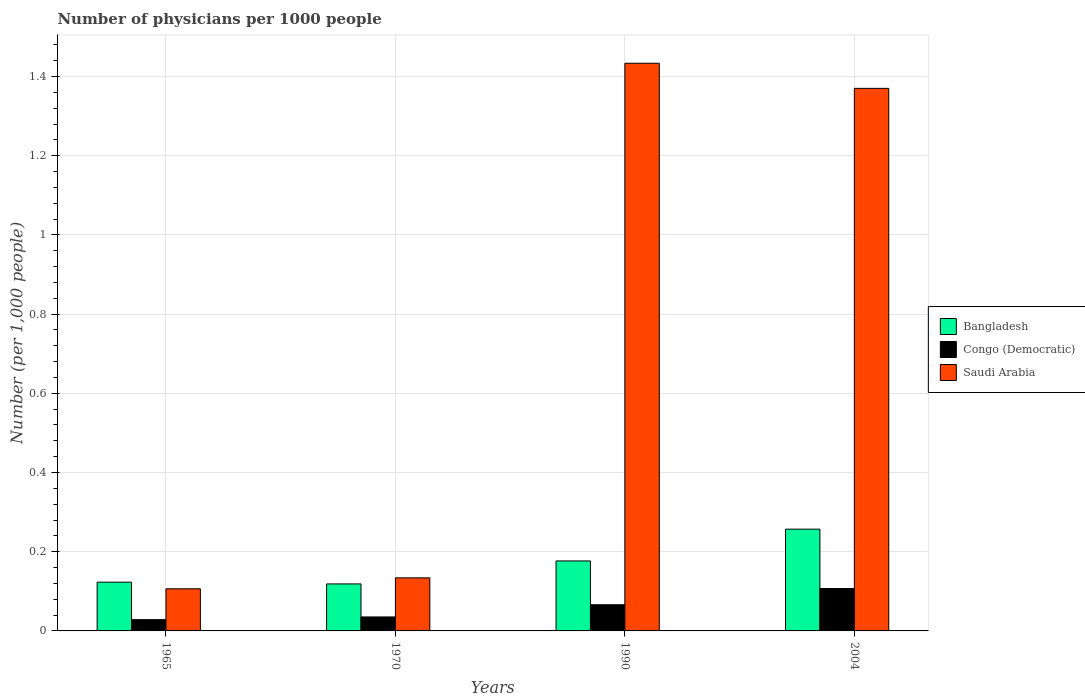Are the number of bars per tick equal to the number of legend labels?
Make the answer very short. Yes. Are the number of bars on each tick of the X-axis equal?
Provide a short and direct response. Yes. How many bars are there on the 1st tick from the left?
Your response must be concise. 3. How many bars are there on the 4th tick from the right?
Make the answer very short. 3. What is the label of the 1st group of bars from the left?
Offer a very short reply. 1965. What is the number of physicians in Saudi Arabia in 1970?
Provide a short and direct response. 0.13. Across all years, what is the maximum number of physicians in Congo (Democratic)?
Give a very brief answer. 0.11. Across all years, what is the minimum number of physicians in Bangladesh?
Provide a short and direct response. 0.12. In which year was the number of physicians in Congo (Democratic) minimum?
Provide a succinct answer. 1965. What is the total number of physicians in Bangladesh in the graph?
Your answer should be very brief. 0.68. What is the difference between the number of physicians in Bangladesh in 1965 and that in 1970?
Provide a succinct answer. 0. What is the difference between the number of physicians in Bangladesh in 1970 and the number of physicians in Saudi Arabia in 1990?
Give a very brief answer. -1.31. What is the average number of physicians in Congo (Democratic) per year?
Your response must be concise. 0.06. In the year 1965, what is the difference between the number of physicians in Bangladesh and number of physicians in Saudi Arabia?
Your answer should be very brief. 0.02. In how many years, is the number of physicians in Saudi Arabia greater than 0.32?
Make the answer very short. 2. What is the ratio of the number of physicians in Bangladesh in 1970 to that in 1990?
Your answer should be compact. 0.67. Is the difference between the number of physicians in Bangladesh in 1965 and 1970 greater than the difference between the number of physicians in Saudi Arabia in 1965 and 1970?
Provide a short and direct response. Yes. What is the difference between the highest and the second highest number of physicians in Bangladesh?
Ensure brevity in your answer.  0.08. What is the difference between the highest and the lowest number of physicians in Bangladesh?
Provide a short and direct response. 0.14. In how many years, is the number of physicians in Saudi Arabia greater than the average number of physicians in Saudi Arabia taken over all years?
Offer a terse response. 2. What does the 2nd bar from the left in 1970 represents?
Give a very brief answer. Congo (Democratic). What does the 2nd bar from the right in 1965 represents?
Ensure brevity in your answer.  Congo (Democratic). Is it the case that in every year, the sum of the number of physicians in Congo (Democratic) and number of physicians in Bangladesh is greater than the number of physicians in Saudi Arabia?
Your response must be concise. No. How many bars are there?
Your response must be concise. 12. How many years are there in the graph?
Your answer should be compact. 4. What is the difference between two consecutive major ticks on the Y-axis?
Keep it short and to the point. 0.2. Does the graph contain grids?
Your answer should be very brief. Yes. Where does the legend appear in the graph?
Your answer should be very brief. Center right. What is the title of the graph?
Offer a very short reply. Number of physicians per 1000 people. Does "United Kingdom" appear as one of the legend labels in the graph?
Offer a very short reply. No. What is the label or title of the Y-axis?
Your answer should be compact. Number (per 1,0 people). What is the Number (per 1,000 people) in Bangladesh in 1965?
Give a very brief answer. 0.12. What is the Number (per 1,000 people) of Congo (Democratic) in 1965?
Make the answer very short. 0.03. What is the Number (per 1,000 people) in Saudi Arabia in 1965?
Your response must be concise. 0.11. What is the Number (per 1,000 people) of Bangladesh in 1970?
Provide a short and direct response. 0.12. What is the Number (per 1,000 people) of Congo (Democratic) in 1970?
Your response must be concise. 0.04. What is the Number (per 1,000 people) in Saudi Arabia in 1970?
Keep it short and to the point. 0.13. What is the Number (per 1,000 people) of Bangladesh in 1990?
Make the answer very short. 0.18. What is the Number (per 1,000 people) of Congo (Democratic) in 1990?
Make the answer very short. 0.07. What is the Number (per 1,000 people) of Saudi Arabia in 1990?
Provide a succinct answer. 1.43. What is the Number (per 1,000 people) in Bangladesh in 2004?
Offer a terse response. 0.26. What is the Number (per 1,000 people) in Congo (Democratic) in 2004?
Provide a succinct answer. 0.11. What is the Number (per 1,000 people) in Saudi Arabia in 2004?
Ensure brevity in your answer.  1.37. Across all years, what is the maximum Number (per 1,000 people) of Bangladesh?
Your answer should be very brief. 0.26. Across all years, what is the maximum Number (per 1,000 people) in Congo (Democratic)?
Provide a short and direct response. 0.11. Across all years, what is the maximum Number (per 1,000 people) in Saudi Arabia?
Offer a very short reply. 1.43. Across all years, what is the minimum Number (per 1,000 people) of Bangladesh?
Ensure brevity in your answer.  0.12. Across all years, what is the minimum Number (per 1,000 people) of Congo (Democratic)?
Offer a terse response. 0.03. Across all years, what is the minimum Number (per 1,000 people) in Saudi Arabia?
Your answer should be compact. 0.11. What is the total Number (per 1,000 people) in Bangladesh in the graph?
Offer a terse response. 0.68. What is the total Number (per 1,000 people) in Congo (Democratic) in the graph?
Offer a terse response. 0.24. What is the total Number (per 1,000 people) of Saudi Arabia in the graph?
Ensure brevity in your answer.  3.04. What is the difference between the Number (per 1,000 people) in Bangladesh in 1965 and that in 1970?
Offer a very short reply. 0. What is the difference between the Number (per 1,000 people) in Congo (Democratic) in 1965 and that in 1970?
Provide a succinct answer. -0.01. What is the difference between the Number (per 1,000 people) of Saudi Arabia in 1965 and that in 1970?
Your answer should be compact. -0.03. What is the difference between the Number (per 1,000 people) in Bangladesh in 1965 and that in 1990?
Make the answer very short. -0.05. What is the difference between the Number (per 1,000 people) of Congo (Democratic) in 1965 and that in 1990?
Your response must be concise. -0.04. What is the difference between the Number (per 1,000 people) of Saudi Arabia in 1965 and that in 1990?
Your response must be concise. -1.33. What is the difference between the Number (per 1,000 people) of Bangladesh in 1965 and that in 2004?
Keep it short and to the point. -0.13. What is the difference between the Number (per 1,000 people) in Congo (Democratic) in 1965 and that in 2004?
Provide a short and direct response. -0.08. What is the difference between the Number (per 1,000 people) in Saudi Arabia in 1965 and that in 2004?
Your response must be concise. -1.26. What is the difference between the Number (per 1,000 people) in Bangladesh in 1970 and that in 1990?
Offer a very short reply. -0.06. What is the difference between the Number (per 1,000 people) in Congo (Democratic) in 1970 and that in 1990?
Your answer should be compact. -0.03. What is the difference between the Number (per 1,000 people) of Saudi Arabia in 1970 and that in 1990?
Your answer should be very brief. -1.3. What is the difference between the Number (per 1,000 people) of Bangladesh in 1970 and that in 2004?
Offer a very short reply. -0.14. What is the difference between the Number (per 1,000 people) of Congo (Democratic) in 1970 and that in 2004?
Offer a terse response. -0.07. What is the difference between the Number (per 1,000 people) of Saudi Arabia in 1970 and that in 2004?
Provide a short and direct response. -1.24. What is the difference between the Number (per 1,000 people) in Bangladesh in 1990 and that in 2004?
Make the answer very short. -0.08. What is the difference between the Number (per 1,000 people) in Congo (Democratic) in 1990 and that in 2004?
Provide a short and direct response. -0.04. What is the difference between the Number (per 1,000 people) of Saudi Arabia in 1990 and that in 2004?
Give a very brief answer. 0.06. What is the difference between the Number (per 1,000 people) of Bangladesh in 1965 and the Number (per 1,000 people) of Congo (Democratic) in 1970?
Your answer should be compact. 0.09. What is the difference between the Number (per 1,000 people) of Bangladesh in 1965 and the Number (per 1,000 people) of Saudi Arabia in 1970?
Your answer should be compact. -0.01. What is the difference between the Number (per 1,000 people) in Congo (Democratic) in 1965 and the Number (per 1,000 people) in Saudi Arabia in 1970?
Offer a very short reply. -0.11. What is the difference between the Number (per 1,000 people) in Bangladesh in 1965 and the Number (per 1,000 people) in Congo (Democratic) in 1990?
Provide a short and direct response. 0.06. What is the difference between the Number (per 1,000 people) of Bangladesh in 1965 and the Number (per 1,000 people) of Saudi Arabia in 1990?
Your answer should be very brief. -1.31. What is the difference between the Number (per 1,000 people) of Congo (Democratic) in 1965 and the Number (per 1,000 people) of Saudi Arabia in 1990?
Keep it short and to the point. -1.41. What is the difference between the Number (per 1,000 people) in Bangladesh in 1965 and the Number (per 1,000 people) in Congo (Democratic) in 2004?
Make the answer very short. 0.02. What is the difference between the Number (per 1,000 people) of Bangladesh in 1965 and the Number (per 1,000 people) of Saudi Arabia in 2004?
Your answer should be compact. -1.25. What is the difference between the Number (per 1,000 people) in Congo (Democratic) in 1965 and the Number (per 1,000 people) in Saudi Arabia in 2004?
Ensure brevity in your answer.  -1.34. What is the difference between the Number (per 1,000 people) of Bangladesh in 1970 and the Number (per 1,000 people) of Congo (Democratic) in 1990?
Provide a short and direct response. 0.05. What is the difference between the Number (per 1,000 people) of Bangladesh in 1970 and the Number (per 1,000 people) of Saudi Arabia in 1990?
Your answer should be compact. -1.31. What is the difference between the Number (per 1,000 people) of Congo (Democratic) in 1970 and the Number (per 1,000 people) of Saudi Arabia in 1990?
Give a very brief answer. -1.4. What is the difference between the Number (per 1,000 people) of Bangladesh in 1970 and the Number (per 1,000 people) of Congo (Democratic) in 2004?
Keep it short and to the point. 0.01. What is the difference between the Number (per 1,000 people) in Bangladesh in 1970 and the Number (per 1,000 people) in Saudi Arabia in 2004?
Your answer should be compact. -1.25. What is the difference between the Number (per 1,000 people) of Congo (Democratic) in 1970 and the Number (per 1,000 people) of Saudi Arabia in 2004?
Provide a succinct answer. -1.33. What is the difference between the Number (per 1,000 people) of Bangladesh in 1990 and the Number (per 1,000 people) of Congo (Democratic) in 2004?
Provide a succinct answer. 0.07. What is the difference between the Number (per 1,000 people) in Bangladesh in 1990 and the Number (per 1,000 people) in Saudi Arabia in 2004?
Ensure brevity in your answer.  -1.19. What is the difference between the Number (per 1,000 people) in Congo (Democratic) in 1990 and the Number (per 1,000 people) in Saudi Arabia in 2004?
Provide a short and direct response. -1.3. What is the average Number (per 1,000 people) in Bangladesh per year?
Your answer should be compact. 0.17. What is the average Number (per 1,000 people) of Congo (Democratic) per year?
Make the answer very short. 0.06. What is the average Number (per 1,000 people) of Saudi Arabia per year?
Offer a very short reply. 0.76. In the year 1965, what is the difference between the Number (per 1,000 people) in Bangladesh and Number (per 1,000 people) in Congo (Democratic)?
Give a very brief answer. 0.09. In the year 1965, what is the difference between the Number (per 1,000 people) of Bangladesh and Number (per 1,000 people) of Saudi Arabia?
Provide a short and direct response. 0.02. In the year 1965, what is the difference between the Number (per 1,000 people) of Congo (Democratic) and Number (per 1,000 people) of Saudi Arabia?
Your answer should be very brief. -0.08. In the year 1970, what is the difference between the Number (per 1,000 people) in Bangladesh and Number (per 1,000 people) in Congo (Democratic)?
Offer a terse response. 0.08. In the year 1970, what is the difference between the Number (per 1,000 people) of Bangladesh and Number (per 1,000 people) of Saudi Arabia?
Your answer should be compact. -0.02. In the year 1970, what is the difference between the Number (per 1,000 people) in Congo (Democratic) and Number (per 1,000 people) in Saudi Arabia?
Make the answer very short. -0.1. In the year 1990, what is the difference between the Number (per 1,000 people) in Bangladesh and Number (per 1,000 people) in Congo (Democratic)?
Your answer should be compact. 0.11. In the year 1990, what is the difference between the Number (per 1,000 people) in Bangladesh and Number (per 1,000 people) in Saudi Arabia?
Provide a short and direct response. -1.26. In the year 1990, what is the difference between the Number (per 1,000 people) in Congo (Democratic) and Number (per 1,000 people) in Saudi Arabia?
Offer a very short reply. -1.37. In the year 2004, what is the difference between the Number (per 1,000 people) in Bangladesh and Number (per 1,000 people) in Saudi Arabia?
Your response must be concise. -1.11. In the year 2004, what is the difference between the Number (per 1,000 people) in Congo (Democratic) and Number (per 1,000 people) in Saudi Arabia?
Provide a succinct answer. -1.26. What is the ratio of the Number (per 1,000 people) of Bangladesh in 1965 to that in 1970?
Your answer should be compact. 1.04. What is the ratio of the Number (per 1,000 people) of Congo (Democratic) in 1965 to that in 1970?
Provide a short and direct response. 0.81. What is the ratio of the Number (per 1,000 people) in Saudi Arabia in 1965 to that in 1970?
Ensure brevity in your answer.  0.79. What is the ratio of the Number (per 1,000 people) of Bangladesh in 1965 to that in 1990?
Offer a terse response. 0.7. What is the ratio of the Number (per 1,000 people) of Congo (Democratic) in 1965 to that in 1990?
Provide a succinct answer. 0.43. What is the ratio of the Number (per 1,000 people) in Saudi Arabia in 1965 to that in 1990?
Give a very brief answer. 0.07. What is the ratio of the Number (per 1,000 people) in Bangladesh in 1965 to that in 2004?
Your answer should be very brief. 0.48. What is the ratio of the Number (per 1,000 people) of Congo (Democratic) in 1965 to that in 2004?
Provide a short and direct response. 0.27. What is the ratio of the Number (per 1,000 people) of Saudi Arabia in 1965 to that in 2004?
Give a very brief answer. 0.08. What is the ratio of the Number (per 1,000 people) of Bangladesh in 1970 to that in 1990?
Offer a terse response. 0.67. What is the ratio of the Number (per 1,000 people) in Congo (Democratic) in 1970 to that in 1990?
Your response must be concise. 0.53. What is the ratio of the Number (per 1,000 people) of Saudi Arabia in 1970 to that in 1990?
Offer a very short reply. 0.09. What is the ratio of the Number (per 1,000 people) in Bangladesh in 1970 to that in 2004?
Offer a very short reply. 0.46. What is the ratio of the Number (per 1,000 people) in Congo (Democratic) in 1970 to that in 2004?
Provide a short and direct response. 0.33. What is the ratio of the Number (per 1,000 people) in Saudi Arabia in 1970 to that in 2004?
Provide a succinct answer. 0.1. What is the ratio of the Number (per 1,000 people) in Bangladesh in 1990 to that in 2004?
Offer a very short reply. 0.69. What is the ratio of the Number (per 1,000 people) in Congo (Democratic) in 1990 to that in 2004?
Your answer should be compact. 0.62. What is the ratio of the Number (per 1,000 people) in Saudi Arabia in 1990 to that in 2004?
Offer a terse response. 1.05. What is the difference between the highest and the second highest Number (per 1,000 people) of Bangladesh?
Offer a very short reply. 0.08. What is the difference between the highest and the second highest Number (per 1,000 people) in Congo (Democratic)?
Your answer should be very brief. 0.04. What is the difference between the highest and the second highest Number (per 1,000 people) in Saudi Arabia?
Your response must be concise. 0.06. What is the difference between the highest and the lowest Number (per 1,000 people) in Bangladesh?
Offer a very short reply. 0.14. What is the difference between the highest and the lowest Number (per 1,000 people) of Congo (Democratic)?
Your answer should be very brief. 0.08. What is the difference between the highest and the lowest Number (per 1,000 people) of Saudi Arabia?
Give a very brief answer. 1.33. 